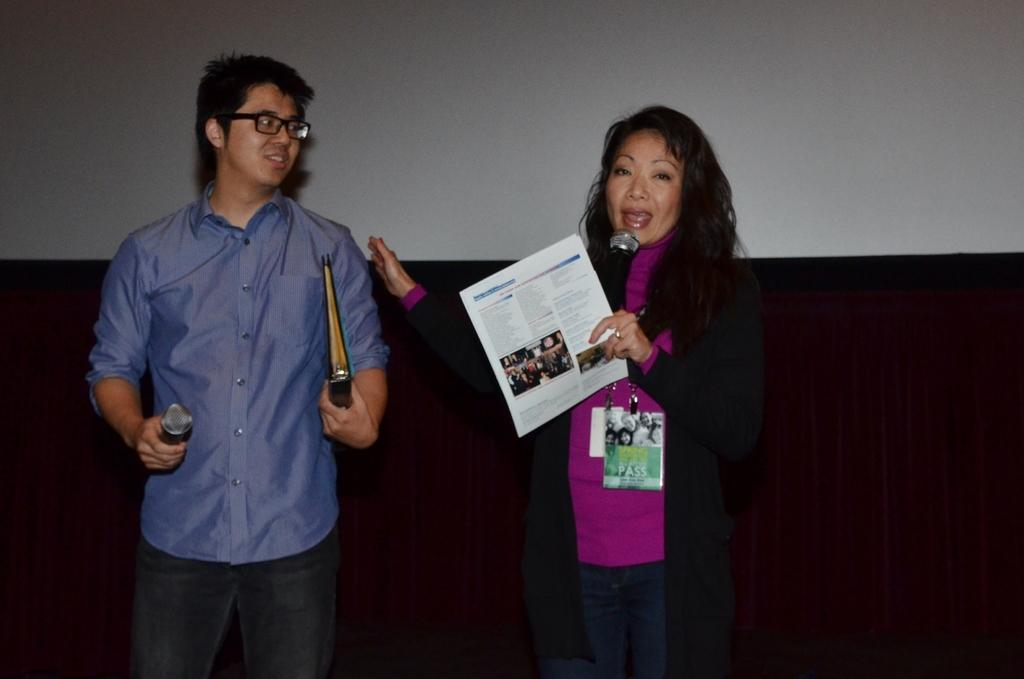How many people are in the image? There are two people in the image. Where is the first person located in the image? The first person is standing on the left side. Where is the second person located in the image? The second person is standing on the right side. What are the people holding in the image? Both people are holding a microphone. What type of eggs can be seen in the image? There are no eggs present in the image. What time of day is it in the image? The time of day cannot be determined from the image. 